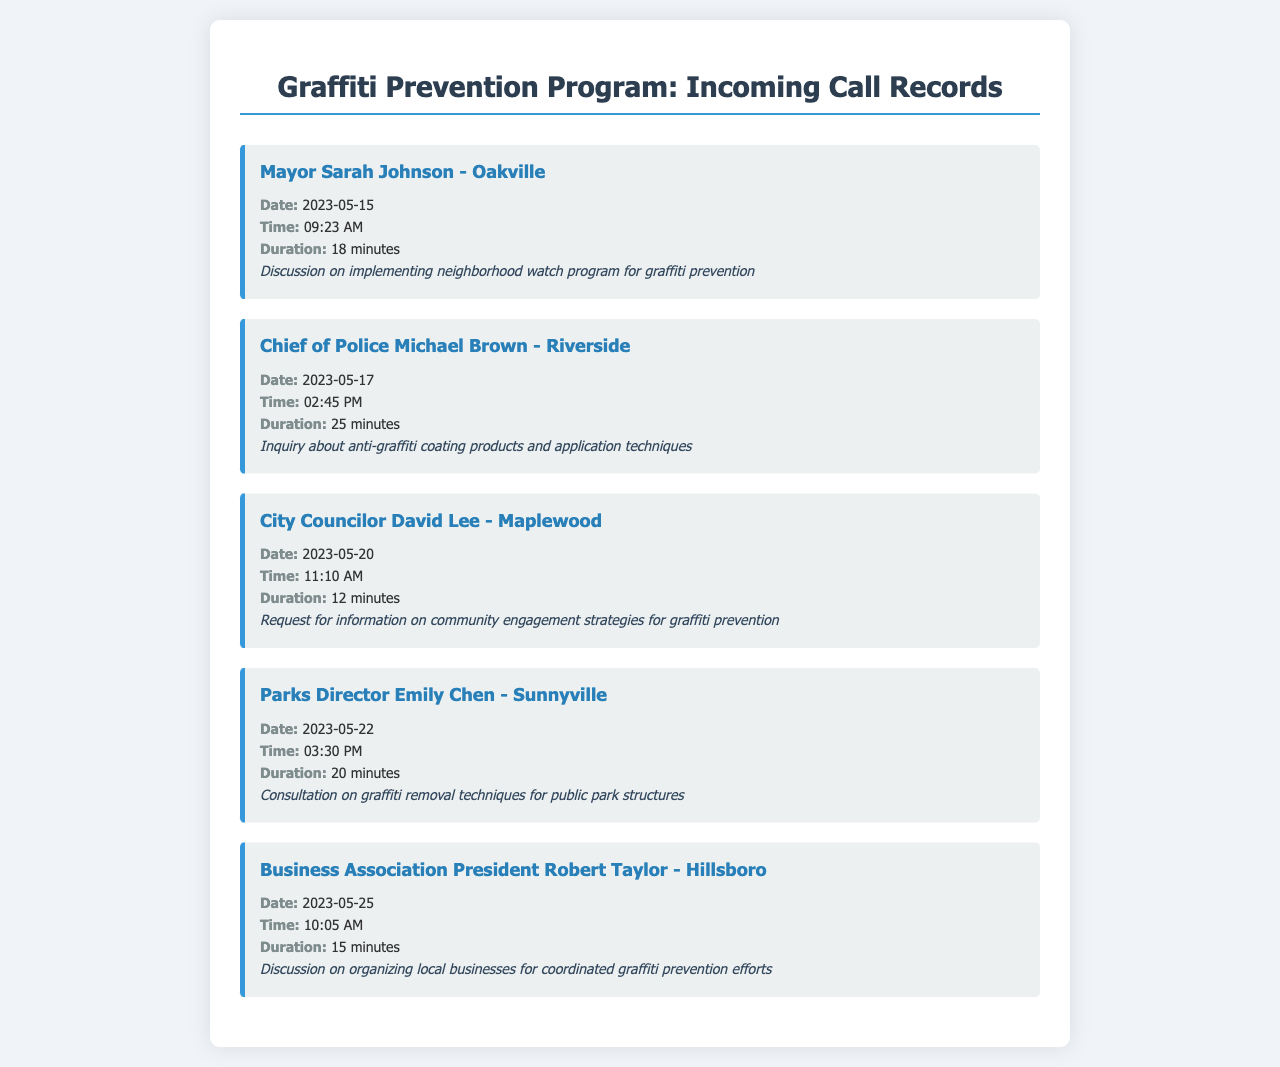What is the name of the caller from Oakville? The name of the caller is provided in the record for the call on 2023-05-15, which indicates that it was Mayor Sarah Johnson.
Answer: Sarah Johnson What date did the call from Riverside occur? The date of the call from Chief of Police Michael Brown is listed in the record as 2023-05-17.
Answer: 2023-05-17 How long was the call with City Councilor David Lee? The duration of the call with City Councilor David Lee on 2023-05-20 is noted in the record as 12 minutes.
Answer: 12 minutes What was the main topic of discussion with Parks Director Emily Chen? The consultation with Parks Director Emily Chen was focused on graffiti removal techniques for public park structures as mentioned in the notes.
Answer: Graffiti removal techniques Who organized a discussion about local businesses for graffiti prevention? The record mentions Business Association President Robert Taylor discussing this topic on 2023-05-25.
Answer: Robert Taylor Which town is Chief of Police Michael Brown from? The document specifies that Chief of Police Michael Brown is from Riverside.
Answer: Riverside 